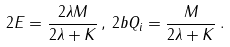<formula> <loc_0><loc_0><loc_500><loc_500>2 E = \frac { 2 \lambda M } { 2 \lambda + K } \, , \, 2 b Q _ { i } = \frac { M } { 2 \lambda + K } \, .</formula> 